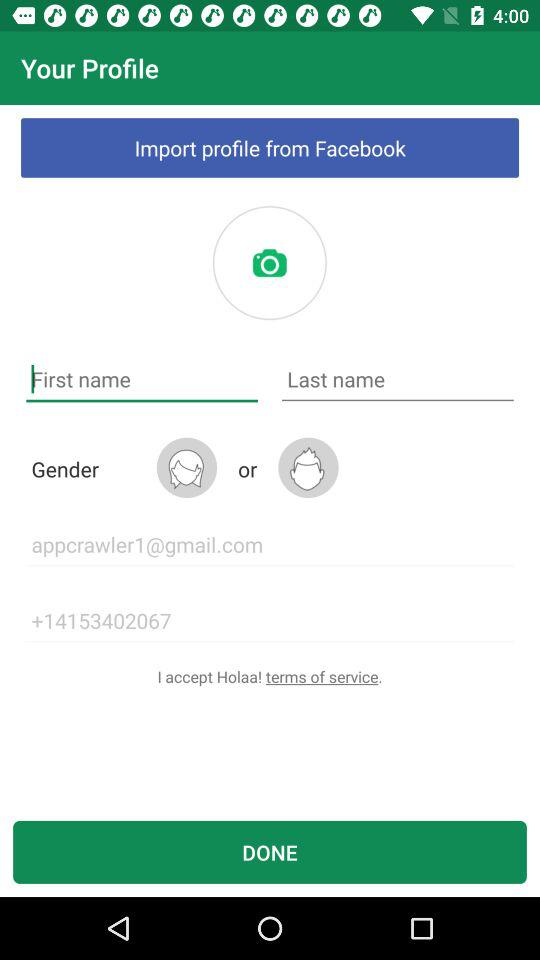What is the email address? The email address is appcrawler1@gmail.com. 